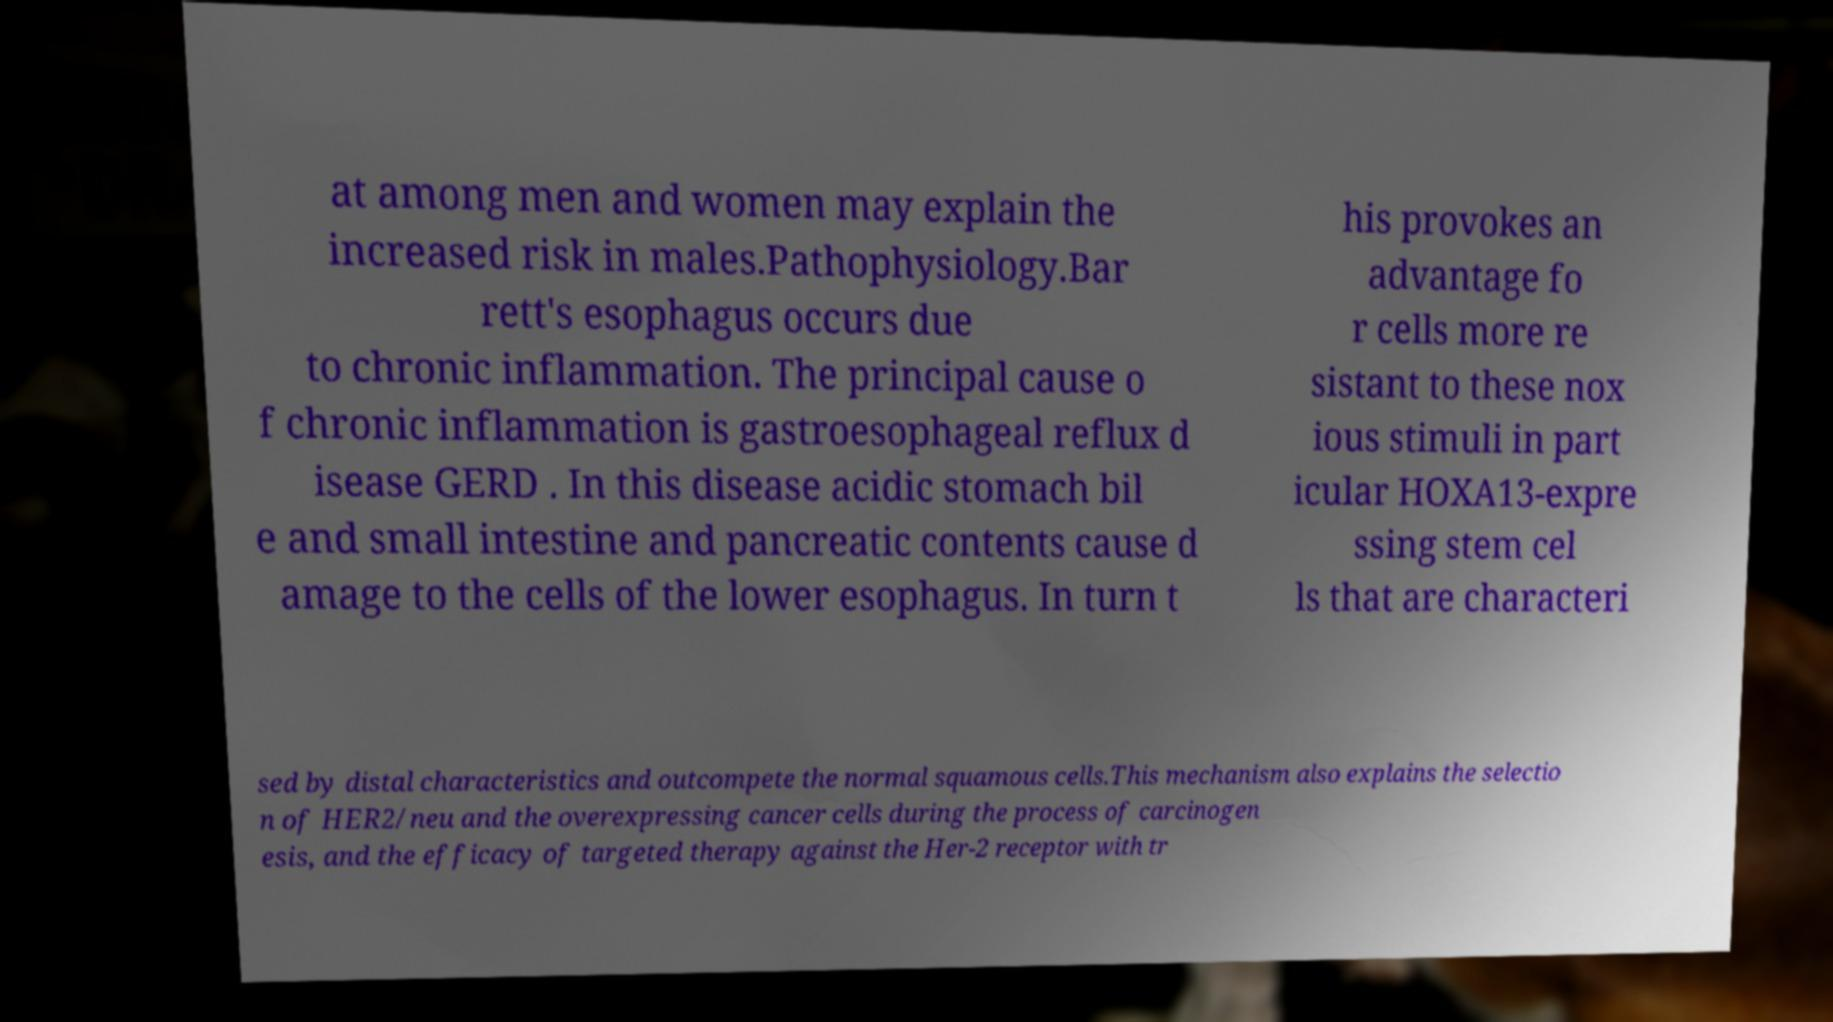Could you extract and type out the text from this image? at among men and women may explain the increased risk in males.Pathophysiology.Bar rett's esophagus occurs due to chronic inflammation. The principal cause o f chronic inflammation is gastroesophageal reflux d isease GERD . In this disease acidic stomach bil e and small intestine and pancreatic contents cause d amage to the cells of the lower esophagus. In turn t his provokes an advantage fo r cells more re sistant to these nox ious stimuli in part icular HOXA13-expre ssing stem cel ls that are characteri sed by distal characteristics and outcompete the normal squamous cells.This mechanism also explains the selectio n of HER2/neu and the overexpressing cancer cells during the process of carcinogen esis, and the efficacy of targeted therapy against the Her-2 receptor with tr 